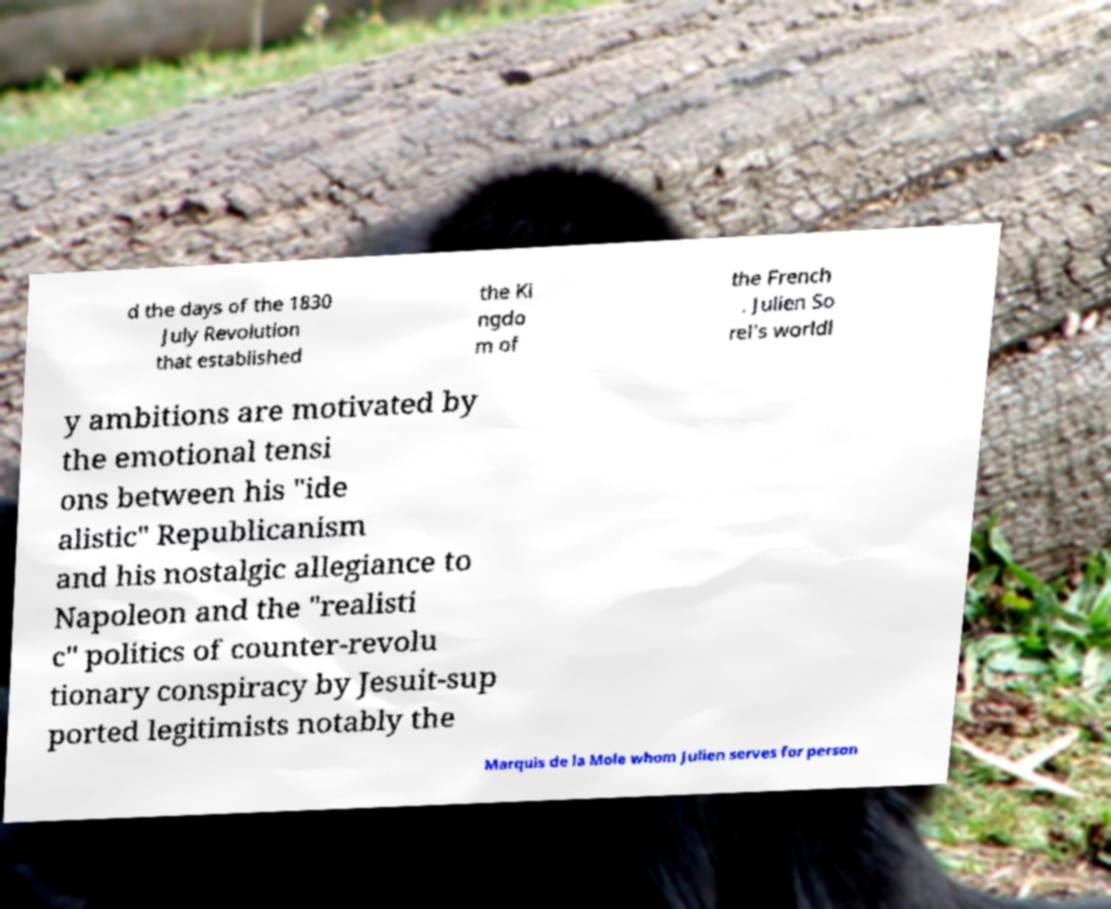I need the written content from this picture converted into text. Can you do that? d the days of the 1830 July Revolution that established the Ki ngdo m of the French . Julien So rel's worldl y ambitions are motivated by the emotional tensi ons between his "ide alistic" Republicanism and his nostalgic allegiance to Napoleon and the "realisti c" politics of counter-revolu tionary conspiracy by Jesuit-sup ported legitimists notably the Marquis de la Mole whom Julien serves for person 